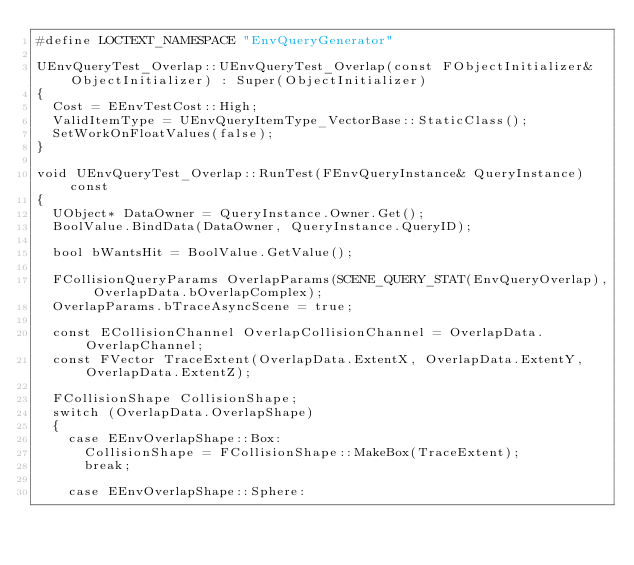<code> <loc_0><loc_0><loc_500><loc_500><_C++_>#define LOCTEXT_NAMESPACE "EnvQueryGenerator"

UEnvQueryTest_Overlap::UEnvQueryTest_Overlap(const FObjectInitializer& ObjectInitializer) : Super(ObjectInitializer)
{
	Cost = EEnvTestCost::High;
	ValidItemType = UEnvQueryItemType_VectorBase::StaticClass();
	SetWorkOnFloatValues(false);
}

void UEnvQueryTest_Overlap::RunTest(FEnvQueryInstance& QueryInstance) const
{
	UObject* DataOwner = QueryInstance.Owner.Get();
	BoolValue.BindData(DataOwner, QueryInstance.QueryID);

	bool bWantsHit = BoolValue.GetValue();
	
	FCollisionQueryParams OverlapParams(SCENE_QUERY_STAT(EnvQueryOverlap), OverlapData.bOverlapComplex);
	OverlapParams.bTraceAsyncScene = true;
	
	const ECollisionChannel OverlapCollisionChannel = OverlapData.OverlapChannel;
	const FVector TraceExtent(OverlapData.ExtentX, OverlapData.ExtentY, OverlapData.ExtentZ);

	FCollisionShape CollisionShape;
	switch (OverlapData.OverlapShape)
	{
		case EEnvOverlapShape::Box:
			CollisionShape = FCollisionShape::MakeBox(TraceExtent);
			break;

		case EEnvOverlapShape::Sphere:</code> 